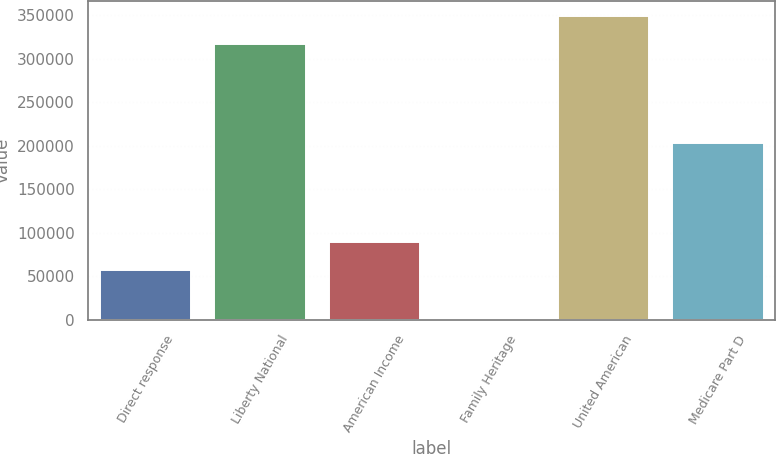Convert chart to OTSL. <chart><loc_0><loc_0><loc_500><loc_500><bar_chart><fcel>Direct response<fcel>Liberty National<fcel>American Income<fcel>Family Heritage<fcel>United American<fcel>Medicare Part D<nl><fcel>57014<fcel>316839<fcel>89252.2<fcel>1.12<fcel>349077<fcel>203340<nl></chart> 